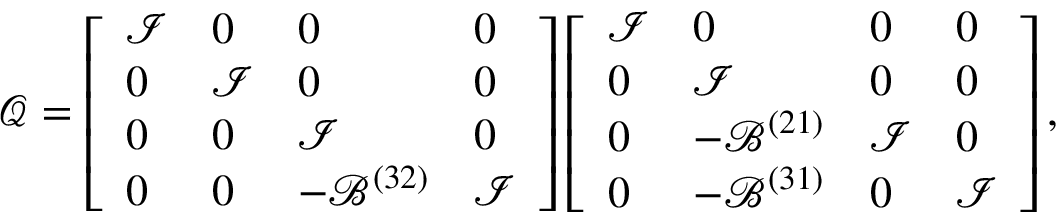Convert formula to latex. <formula><loc_0><loc_0><loc_500><loc_500>\mathcal { Q } = \left [ \begin{array} { l l l l } { \mathcal { I } } & { 0 } & { 0 } & { 0 } \\ { 0 } & { \mathcal { I } } & { 0 } & { 0 } \\ { 0 } & { 0 } & { \mathcal { I } } & { 0 } \\ { 0 } & { 0 } & { - \mathcal { B } ^ { ( 3 2 ) } } & { \mathcal { I } } \end{array} \right ] \left [ \begin{array} { l l l l } { \mathcal { I } } & { 0 } & { 0 } & { 0 } \\ { 0 } & { \mathcal { I } } & { 0 } & { 0 } \\ { 0 } & { - \mathcal { B } ^ { ( 2 1 ) } } & { \mathcal { I } } & { 0 } \\ { 0 } & { - \mathcal { B } ^ { ( 3 1 ) } } & { 0 } & { \mathcal { I } } \end{array} \right ] ,</formula> 